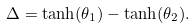<formula> <loc_0><loc_0><loc_500><loc_500>\Delta = \tanh ( \theta _ { 1 } ) - \tanh ( \theta _ { 2 } ) .</formula> 